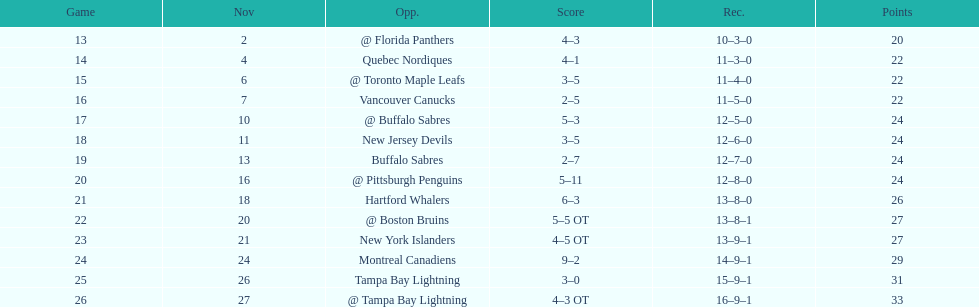Did the tampa bay lightning have the least amount of wins? Yes. 